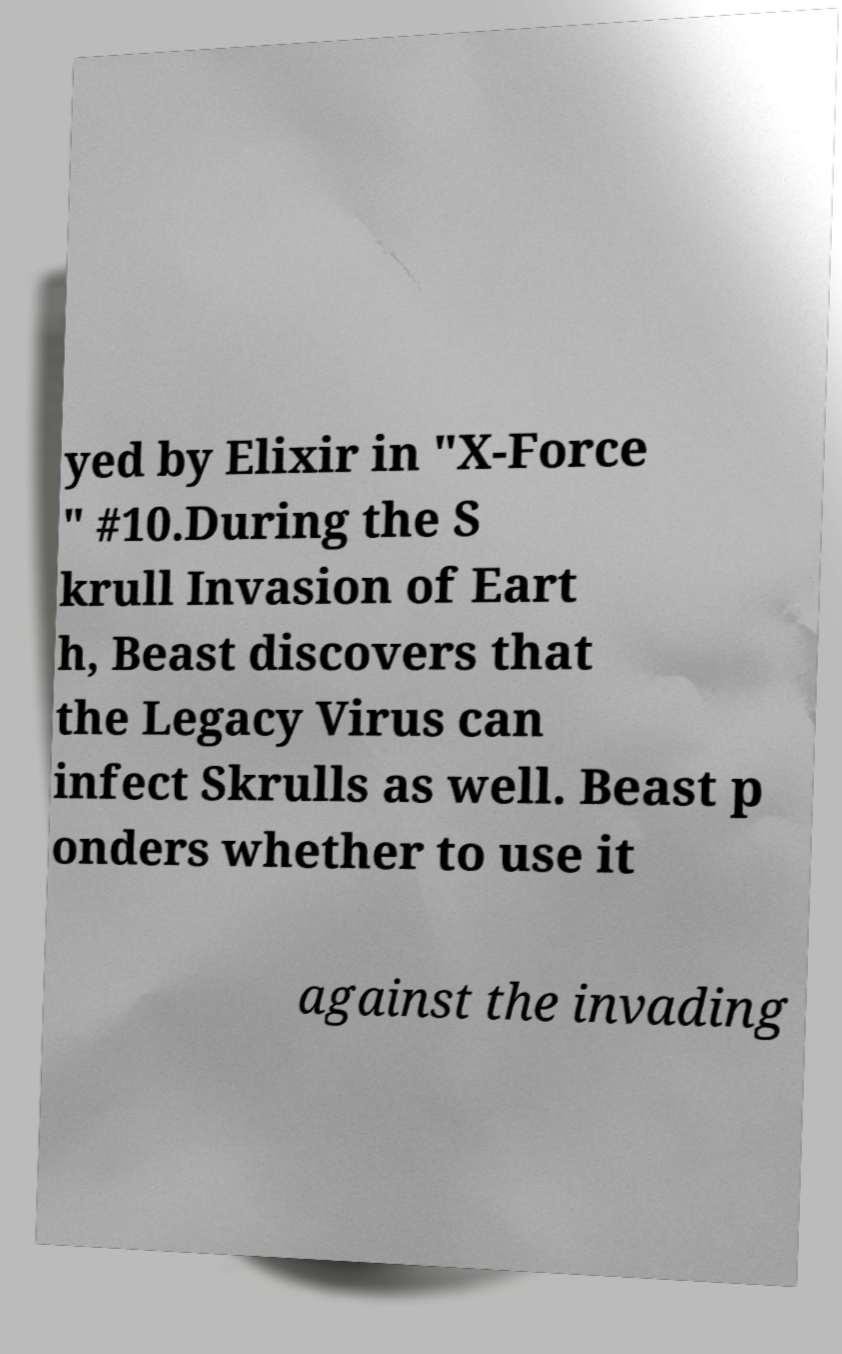I need the written content from this picture converted into text. Can you do that? yed by Elixir in "X-Force " #10.During the S krull Invasion of Eart h, Beast discovers that the Legacy Virus can infect Skrulls as well. Beast p onders whether to use it against the invading 